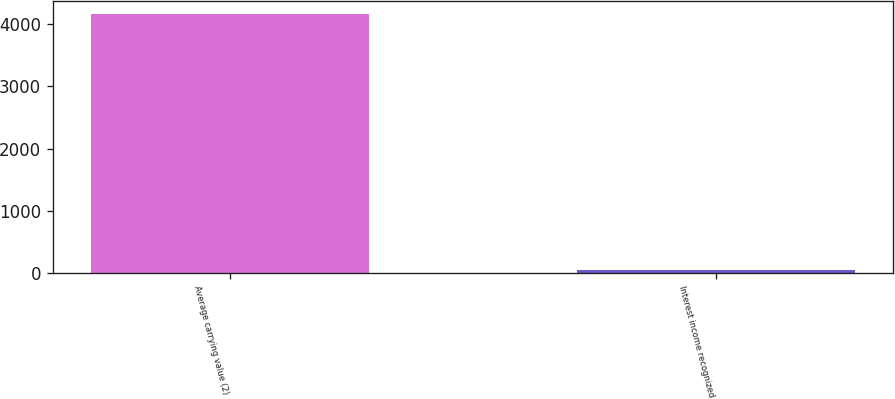Convert chart to OTSL. <chart><loc_0><loc_0><loc_500><loc_500><bar_chart><fcel>Average carrying value (2)<fcel>Interest income recognized<nl><fcel>4157<fcel>49<nl></chart> 